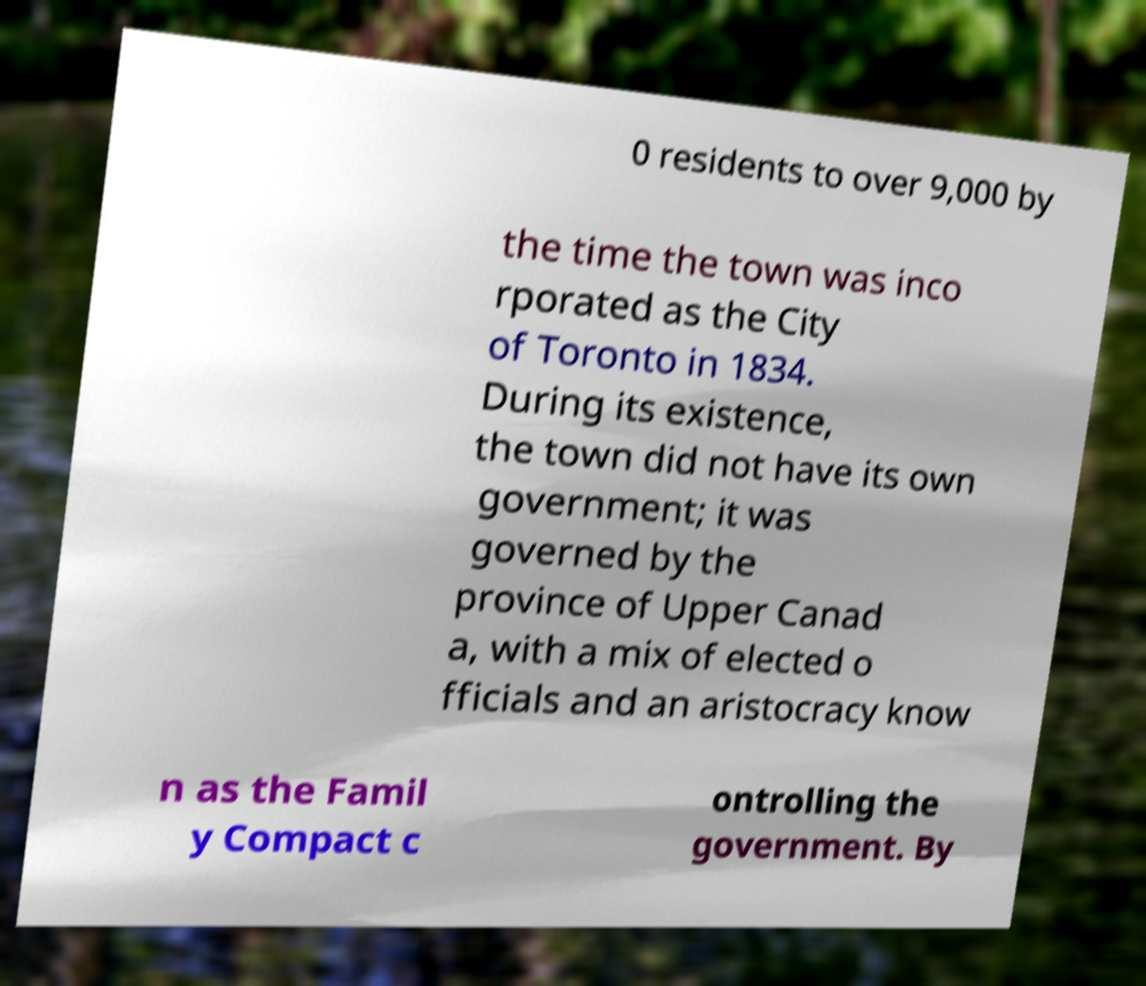Please read and relay the text visible in this image. What does it say? 0 residents to over 9,000 by the time the town was inco rporated as the City of Toronto in 1834. During its existence, the town did not have its own government; it was governed by the province of Upper Canad a, with a mix of elected o fficials and an aristocracy know n as the Famil y Compact c ontrolling the government. By 